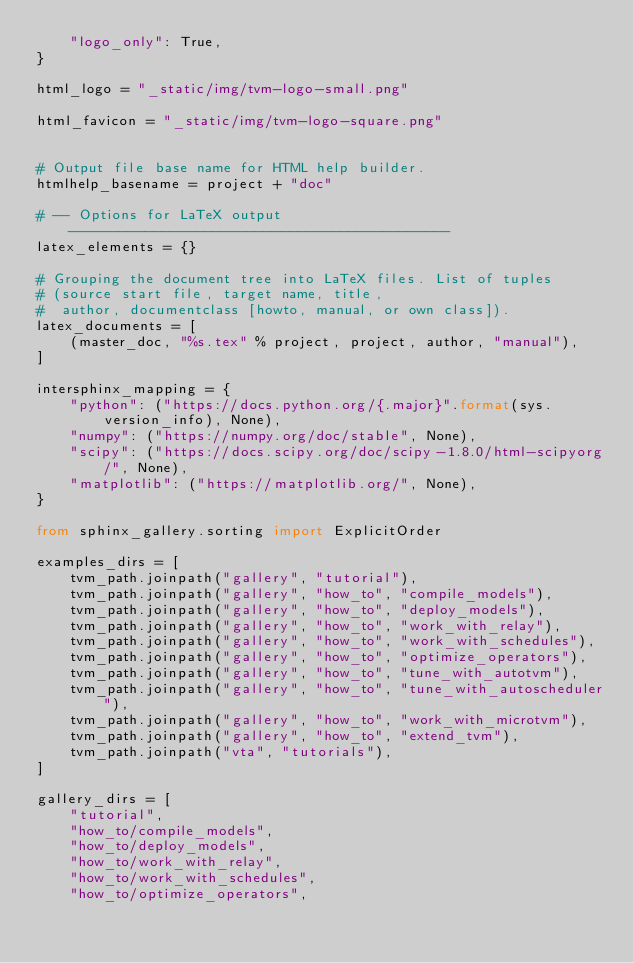<code> <loc_0><loc_0><loc_500><loc_500><_Python_>    "logo_only": True,
}

html_logo = "_static/img/tvm-logo-small.png"

html_favicon = "_static/img/tvm-logo-square.png"


# Output file base name for HTML help builder.
htmlhelp_basename = project + "doc"

# -- Options for LaTeX output ---------------------------------------------
latex_elements = {}

# Grouping the document tree into LaTeX files. List of tuples
# (source start file, target name, title,
#  author, documentclass [howto, manual, or own class]).
latex_documents = [
    (master_doc, "%s.tex" % project, project, author, "manual"),
]

intersphinx_mapping = {
    "python": ("https://docs.python.org/{.major}".format(sys.version_info), None),
    "numpy": ("https://numpy.org/doc/stable", None),
    "scipy": ("https://docs.scipy.org/doc/scipy-1.8.0/html-scipyorg/", None),
    "matplotlib": ("https://matplotlib.org/", None),
}

from sphinx_gallery.sorting import ExplicitOrder

examples_dirs = [
    tvm_path.joinpath("gallery", "tutorial"),
    tvm_path.joinpath("gallery", "how_to", "compile_models"),
    tvm_path.joinpath("gallery", "how_to", "deploy_models"),
    tvm_path.joinpath("gallery", "how_to", "work_with_relay"),
    tvm_path.joinpath("gallery", "how_to", "work_with_schedules"),
    tvm_path.joinpath("gallery", "how_to", "optimize_operators"),
    tvm_path.joinpath("gallery", "how_to", "tune_with_autotvm"),
    tvm_path.joinpath("gallery", "how_to", "tune_with_autoscheduler"),
    tvm_path.joinpath("gallery", "how_to", "work_with_microtvm"),
    tvm_path.joinpath("gallery", "how_to", "extend_tvm"),
    tvm_path.joinpath("vta", "tutorials"),
]

gallery_dirs = [
    "tutorial",
    "how_to/compile_models",
    "how_to/deploy_models",
    "how_to/work_with_relay",
    "how_to/work_with_schedules",
    "how_to/optimize_operators",</code> 